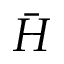<formula> <loc_0><loc_0><loc_500><loc_500>\bar { H }</formula> 